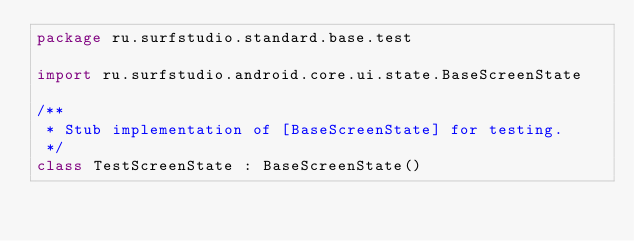<code> <loc_0><loc_0><loc_500><loc_500><_Kotlin_>package ru.surfstudio.standard.base.test

import ru.surfstudio.android.core.ui.state.BaseScreenState

/**
 * Stub implementation of [BaseScreenState] for testing.
 */
class TestScreenState : BaseScreenState()</code> 